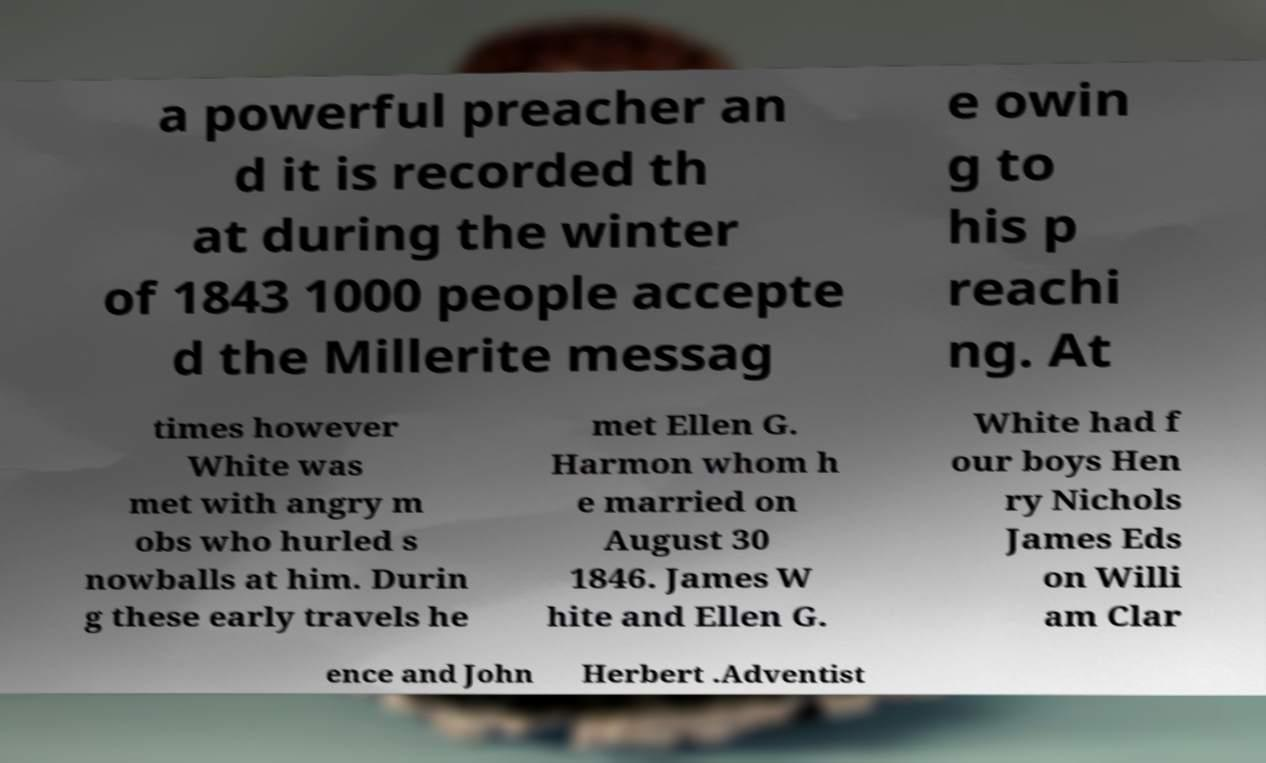Could you assist in decoding the text presented in this image and type it out clearly? a powerful preacher an d it is recorded th at during the winter of 1843 1000 people accepte d the Millerite messag e owin g to his p reachi ng. At times however White was met with angry m obs who hurled s nowballs at him. Durin g these early travels he met Ellen G. Harmon whom h e married on August 30 1846. James W hite and Ellen G. White had f our boys Hen ry Nichols James Eds on Willi am Clar ence and John Herbert .Adventist 